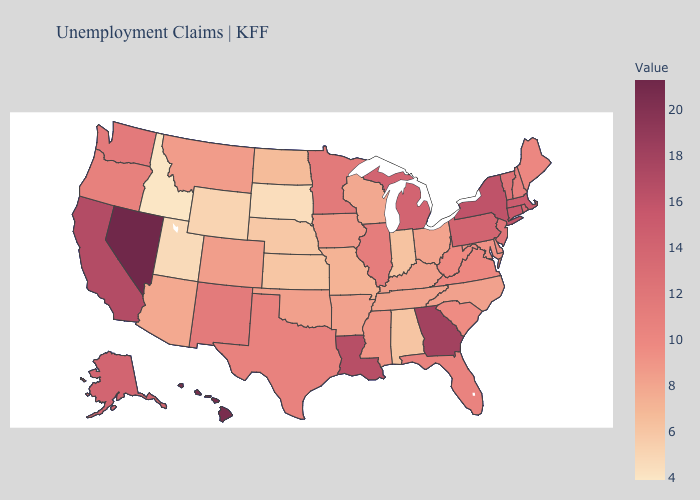Does Nevada have the highest value in the USA?
Write a very short answer. Yes. Among the states that border West Virginia , does Pennsylvania have the highest value?
Give a very brief answer. Yes. Among the states that border Nevada , does California have the highest value?
Keep it brief. Yes. Does Michigan have a higher value than Wisconsin?
Give a very brief answer. Yes. Does the map have missing data?
Concise answer only. No. Which states have the lowest value in the USA?
Give a very brief answer. Idaho. 